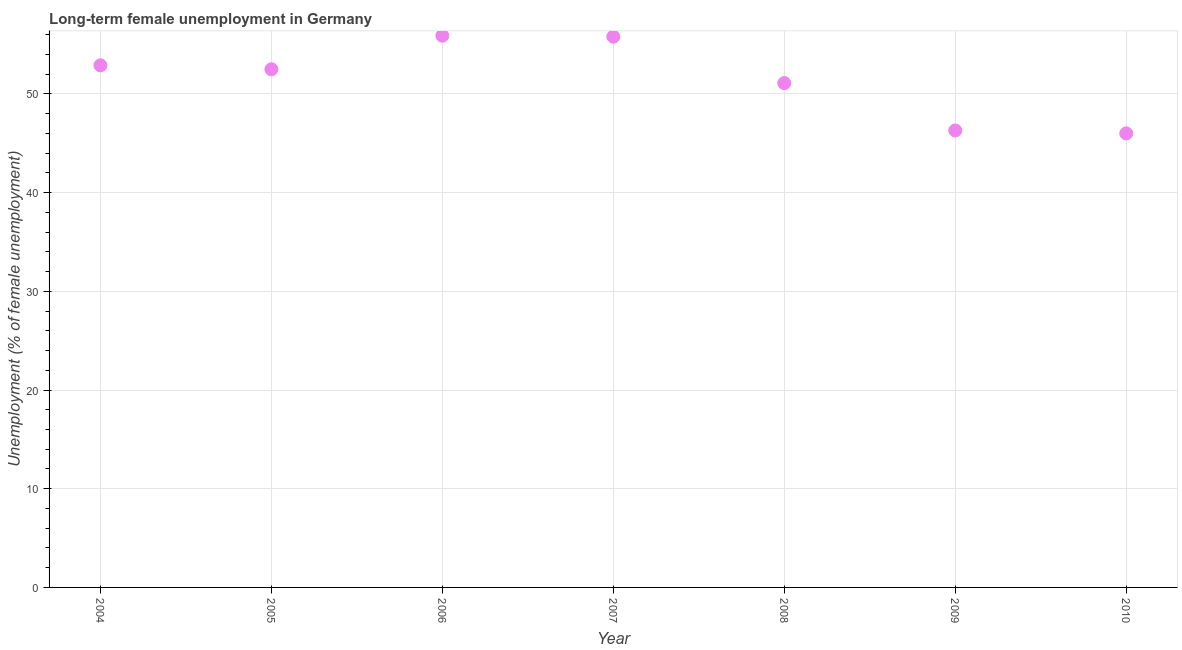What is the long-term female unemployment in 2007?
Your response must be concise. 55.8. Across all years, what is the maximum long-term female unemployment?
Provide a succinct answer. 55.9. In which year was the long-term female unemployment maximum?
Ensure brevity in your answer.  2006. In which year was the long-term female unemployment minimum?
Offer a terse response. 2010. What is the sum of the long-term female unemployment?
Make the answer very short. 360.5. What is the difference between the long-term female unemployment in 2004 and 2005?
Your answer should be compact. 0.4. What is the average long-term female unemployment per year?
Your response must be concise. 51.5. What is the median long-term female unemployment?
Make the answer very short. 52.5. In how many years, is the long-term female unemployment greater than 20 %?
Offer a very short reply. 7. Do a majority of the years between 2005 and 2007 (inclusive) have long-term female unemployment greater than 12 %?
Offer a very short reply. Yes. What is the ratio of the long-term female unemployment in 2005 to that in 2008?
Provide a short and direct response. 1.03. Is the long-term female unemployment in 2004 less than that in 2010?
Offer a very short reply. No. What is the difference between the highest and the second highest long-term female unemployment?
Provide a short and direct response. 0.1. Is the sum of the long-term female unemployment in 2007 and 2009 greater than the maximum long-term female unemployment across all years?
Make the answer very short. Yes. What is the difference between the highest and the lowest long-term female unemployment?
Your answer should be very brief. 9.9. In how many years, is the long-term female unemployment greater than the average long-term female unemployment taken over all years?
Your answer should be compact. 4. Does the long-term female unemployment monotonically increase over the years?
Your answer should be very brief. No. How many dotlines are there?
Provide a short and direct response. 1. Are the values on the major ticks of Y-axis written in scientific E-notation?
Ensure brevity in your answer.  No. Does the graph contain any zero values?
Offer a very short reply. No. Does the graph contain grids?
Offer a very short reply. Yes. What is the title of the graph?
Your response must be concise. Long-term female unemployment in Germany. What is the label or title of the Y-axis?
Your response must be concise. Unemployment (% of female unemployment). What is the Unemployment (% of female unemployment) in 2004?
Your answer should be very brief. 52.9. What is the Unemployment (% of female unemployment) in 2005?
Keep it short and to the point. 52.5. What is the Unemployment (% of female unemployment) in 2006?
Provide a short and direct response. 55.9. What is the Unemployment (% of female unemployment) in 2007?
Give a very brief answer. 55.8. What is the Unemployment (% of female unemployment) in 2008?
Offer a very short reply. 51.1. What is the Unemployment (% of female unemployment) in 2009?
Give a very brief answer. 46.3. What is the difference between the Unemployment (% of female unemployment) in 2004 and 2005?
Make the answer very short. 0.4. What is the difference between the Unemployment (% of female unemployment) in 2004 and 2007?
Give a very brief answer. -2.9. What is the difference between the Unemployment (% of female unemployment) in 2005 and 2006?
Offer a very short reply. -3.4. What is the difference between the Unemployment (% of female unemployment) in 2006 and 2008?
Keep it short and to the point. 4.8. What is the difference between the Unemployment (% of female unemployment) in 2006 and 2010?
Provide a short and direct response. 9.9. What is the difference between the Unemployment (% of female unemployment) in 2007 and 2008?
Your response must be concise. 4.7. What is the difference between the Unemployment (% of female unemployment) in 2007 and 2010?
Keep it short and to the point. 9.8. What is the difference between the Unemployment (% of female unemployment) in 2008 and 2009?
Offer a very short reply. 4.8. What is the difference between the Unemployment (% of female unemployment) in 2008 and 2010?
Your response must be concise. 5.1. What is the ratio of the Unemployment (% of female unemployment) in 2004 to that in 2005?
Your answer should be compact. 1.01. What is the ratio of the Unemployment (% of female unemployment) in 2004 to that in 2006?
Keep it short and to the point. 0.95. What is the ratio of the Unemployment (% of female unemployment) in 2004 to that in 2007?
Ensure brevity in your answer.  0.95. What is the ratio of the Unemployment (% of female unemployment) in 2004 to that in 2008?
Offer a terse response. 1.03. What is the ratio of the Unemployment (% of female unemployment) in 2004 to that in 2009?
Provide a short and direct response. 1.14. What is the ratio of the Unemployment (% of female unemployment) in 2004 to that in 2010?
Provide a succinct answer. 1.15. What is the ratio of the Unemployment (% of female unemployment) in 2005 to that in 2006?
Offer a very short reply. 0.94. What is the ratio of the Unemployment (% of female unemployment) in 2005 to that in 2007?
Your answer should be compact. 0.94. What is the ratio of the Unemployment (% of female unemployment) in 2005 to that in 2008?
Keep it short and to the point. 1.03. What is the ratio of the Unemployment (% of female unemployment) in 2005 to that in 2009?
Provide a succinct answer. 1.13. What is the ratio of the Unemployment (% of female unemployment) in 2005 to that in 2010?
Provide a succinct answer. 1.14. What is the ratio of the Unemployment (% of female unemployment) in 2006 to that in 2007?
Ensure brevity in your answer.  1. What is the ratio of the Unemployment (% of female unemployment) in 2006 to that in 2008?
Offer a terse response. 1.09. What is the ratio of the Unemployment (% of female unemployment) in 2006 to that in 2009?
Your answer should be very brief. 1.21. What is the ratio of the Unemployment (% of female unemployment) in 2006 to that in 2010?
Keep it short and to the point. 1.22. What is the ratio of the Unemployment (% of female unemployment) in 2007 to that in 2008?
Make the answer very short. 1.09. What is the ratio of the Unemployment (% of female unemployment) in 2007 to that in 2009?
Keep it short and to the point. 1.21. What is the ratio of the Unemployment (% of female unemployment) in 2007 to that in 2010?
Your response must be concise. 1.21. What is the ratio of the Unemployment (% of female unemployment) in 2008 to that in 2009?
Offer a terse response. 1.1. What is the ratio of the Unemployment (% of female unemployment) in 2008 to that in 2010?
Your answer should be compact. 1.11. 